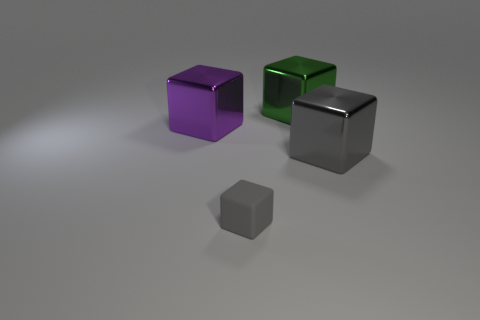What material is the green object?
Offer a terse response. Metal. What is the gray thing that is on the left side of the green object behind the gray block that is behind the tiny matte object made of?
Keep it short and to the point. Rubber. Is the color of the tiny block the same as the large metallic cube that is in front of the large purple shiny cube?
Ensure brevity in your answer.  Yes. What color is the cube in front of the gray cube that is to the right of the small thing?
Your answer should be very brief. Gray. What number of big gray metal things are there?
Give a very brief answer. 1. How many shiny things are cubes or tiny objects?
Your response must be concise. 3. What number of cubes have the same color as the small rubber thing?
Offer a terse response. 1. What is the big object that is on the left side of the gray thing left of the large green shiny object made of?
Provide a short and direct response. Metal. What is the size of the rubber cube?
Provide a short and direct response. Small. What number of gray blocks have the same size as the green shiny block?
Ensure brevity in your answer.  1. 